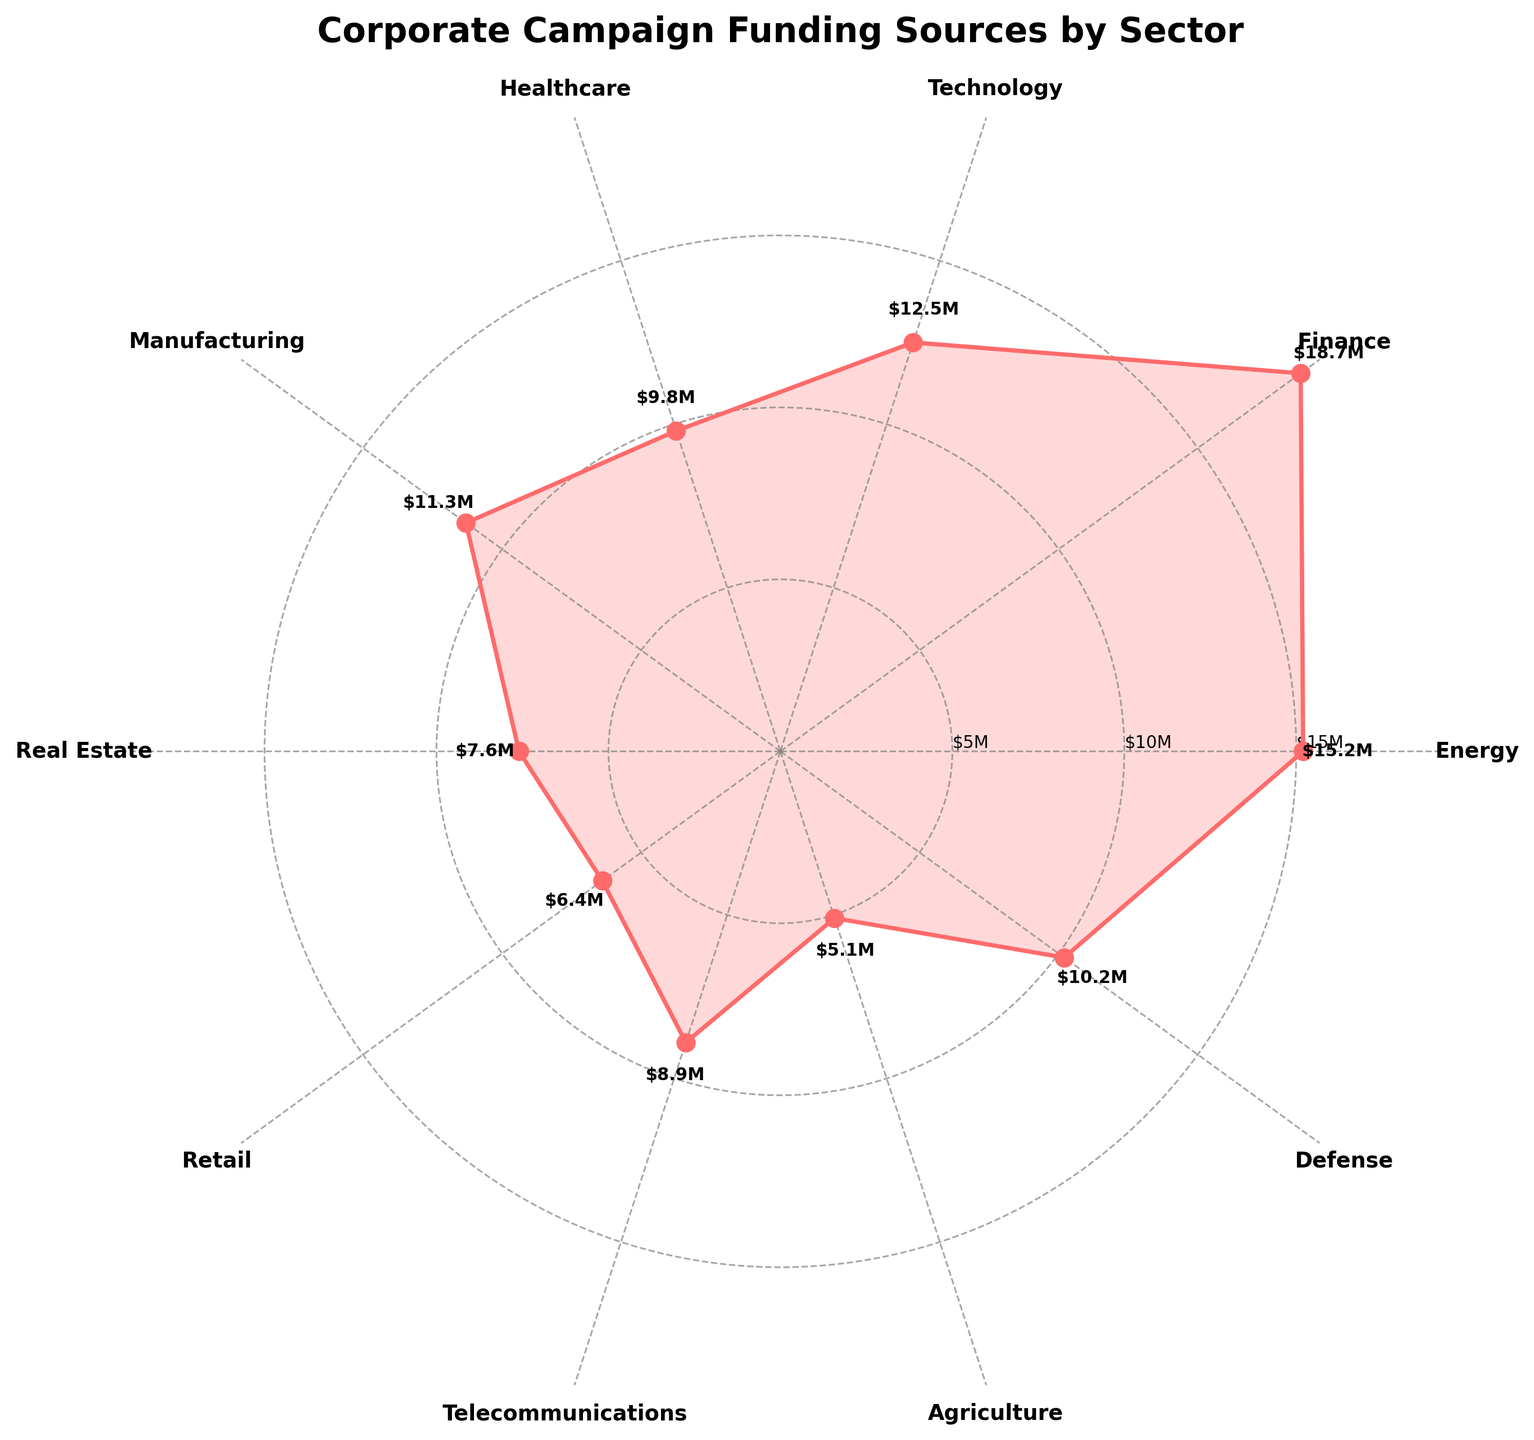What is the title of the chart? The title of the chart is located at the top of the figure. It states the main topic of the visual representation.
Answer: Corporate Campaign Funding Sources by Sector What sector has the highest funding? By looking at the lengths of the sectors' sections and their labels, the sector with the highest point on the plot corresponds to the one that has the maximum funding value.
Answer: Finance How much funding did the Agriculture sector receive? The value for Agriculture can be found by locating the Agriculture label on the plot and then looking at the radius where it intersects the plotted line.
Answer: $5.1M Which two sectors have the closest funding amounts? By comparing the lengths of the sectors' segments visually, two sectors that have similar distances from the center of the plot indicate similar funding amounts.
Answer: Manufacturing and Defense Which sector's funding is slightly lower than Telecommunications but higher than Healthcare? Find Healthcare and Telecommunications sectors and compare the funding values of neighboring sectors.
Answer: Defense How many sectors received funding of more than $10M? Locate the sectors with funding amounts greater than $10M by reading the labels and the associated funding values.
Answer: 5 sectors Is the funding for Technology greater than the combined funding for Retail and Real Estate? First, sum the funding for Retail ($6.4M) and Real Estate ($7.6M). Then, compare this sum to the Technology funding ($12.5M). Retail + Real Estate = $14.0M, which is greater than Technology's $12.5M.
Answer: No What is the average funding among all sectors? Sum the funding for all sectors and divide by the number of sectors. The sum is $105.7M and there are 10 sectors. The average is $105.7M / 10 = $10.57M.
Answer: $10.57M In the chart, which sector is positioned at the angle just before the Finance sector? By following the circular pattern counterclockwise, identify the sector that comes directly before Finance.
Answer: Energy 